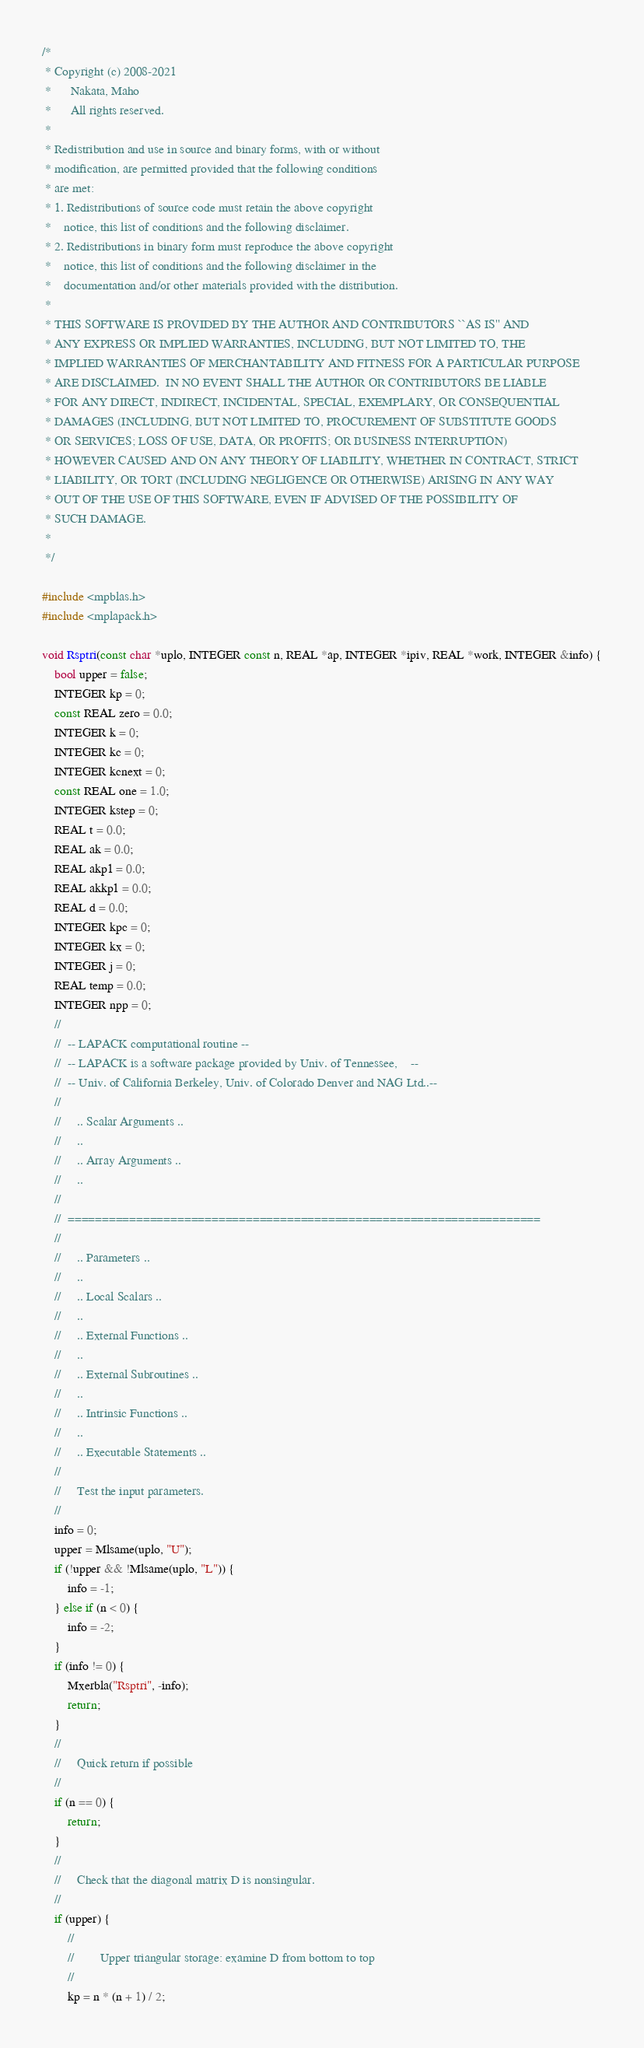Convert code to text. <code><loc_0><loc_0><loc_500><loc_500><_C++_>/*
 * Copyright (c) 2008-2021
 *      Nakata, Maho
 *      All rights reserved.
 *
 * Redistribution and use in source and binary forms, with or without
 * modification, are permitted provided that the following conditions
 * are met:
 * 1. Redistributions of source code must retain the above copyright
 *    notice, this list of conditions and the following disclaimer.
 * 2. Redistributions in binary form must reproduce the above copyright
 *    notice, this list of conditions and the following disclaimer in the
 *    documentation and/or other materials provided with the distribution.
 *
 * THIS SOFTWARE IS PROVIDED BY THE AUTHOR AND CONTRIBUTORS ``AS IS'' AND
 * ANY EXPRESS OR IMPLIED WARRANTIES, INCLUDING, BUT NOT LIMITED TO, THE
 * IMPLIED WARRANTIES OF MERCHANTABILITY AND FITNESS FOR A PARTICULAR PURPOSE
 * ARE DISCLAIMED.  IN NO EVENT SHALL THE AUTHOR OR CONTRIBUTORS BE LIABLE
 * FOR ANY DIRECT, INDIRECT, INCIDENTAL, SPECIAL, EXEMPLARY, OR CONSEQUENTIAL
 * DAMAGES (INCLUDING, BUT NOT LIMITED TO, PROCUREMENT OF SUBSTITUTE GOODS
 * OR SERVICES; LOSS OF USE, DATA, OR PROFITS; OR BUSINESS INTERRUPTION)
 * HOWEVER CAUSED AND ON ANY THEORY OF LIABILITY, WHETHER IN CONTRACT, STRICT
 * LIABILITY, OR TORT (INCLUDING NEGLIGENCE OR OTHERWISE) ARISING IN ANY WAY
 * OUT OF THE USE OF THIS SOFTWARE, EVEN IF ADVISED OF THE POSSIBILITY OF
 * SUCH DAMAGE.
 *
 */

#include <mpblas.h>
#include <mplapack.h>

void Rsptri(const char *uplo, INTEGER const n, REAL *ap, INTEGER *ipiv, REAL *work, INTEGER &info) {
    bool upper = false;
    INTEGER kp = 0;
    const REAL zero = 0.0;
    INTEGER k = 0;
    INTEGER kc = 0;
    INTEGER kcnext = 0;
    const REAL one = 1.0;
    INTEGER kstep = 0;
    REAL t = 0.0;
    REAL ak = 0.0;
    REAL akp1 = 0.0;
    REAL akkp1 = 0.0;
    REAL d = 0.0;
    INTEGER kpc = 0;
    INTEGER kx = 0;
    INTEGER j = 0;
    REAL temp = 0.0;
    INTEGER npp = 0;
    //
    //  -- LAPACK computational routine --
    //  -- LAPACK is a software package provided by Univ. of Tennessee,    --
    //  -- Univ. of California Berkeley, Univ. of Colorado Denver and NAG Ltd..--
    //
    //     .. Scalar Arguments ..
    //     ..
    //     .. Array Arguments ..
    //     ..
    //
    //  =====================================================================
    //
    //     .. Parameters ..
    //     ..
    //     .. Local Scalars ..
    //     ..
    //     .. External Functions ..
    //     ..
    //     .. External Subroutines ..
    //     ..
    //     .. Intrinsic Functions ..
    //     ..
    //     .. Executable Statements ..
    //
    //     Test the input parameters.
    //
    info = 0;
    upper = Mlsame(uplo, "U");
    if (!upper && !Mlsame(uplo, "L")) {
        info = -1;
    } else if (n < 0) {
        info = -2;
    }
    if (info != 0) {
        Mxerbla("Rsptri", -info);
        return;
    }
    //
    //     Quick return if possible
    //
    if (n == 0) {
        return;
    }
    //
    //     Check that the diagonal matrix D is nonsingular.
    //
    if (upper) {
        //
        //        Upper triangular storage: examine D from bottom to top
        //
        kp = n * (n + 1) / 2;</code> 